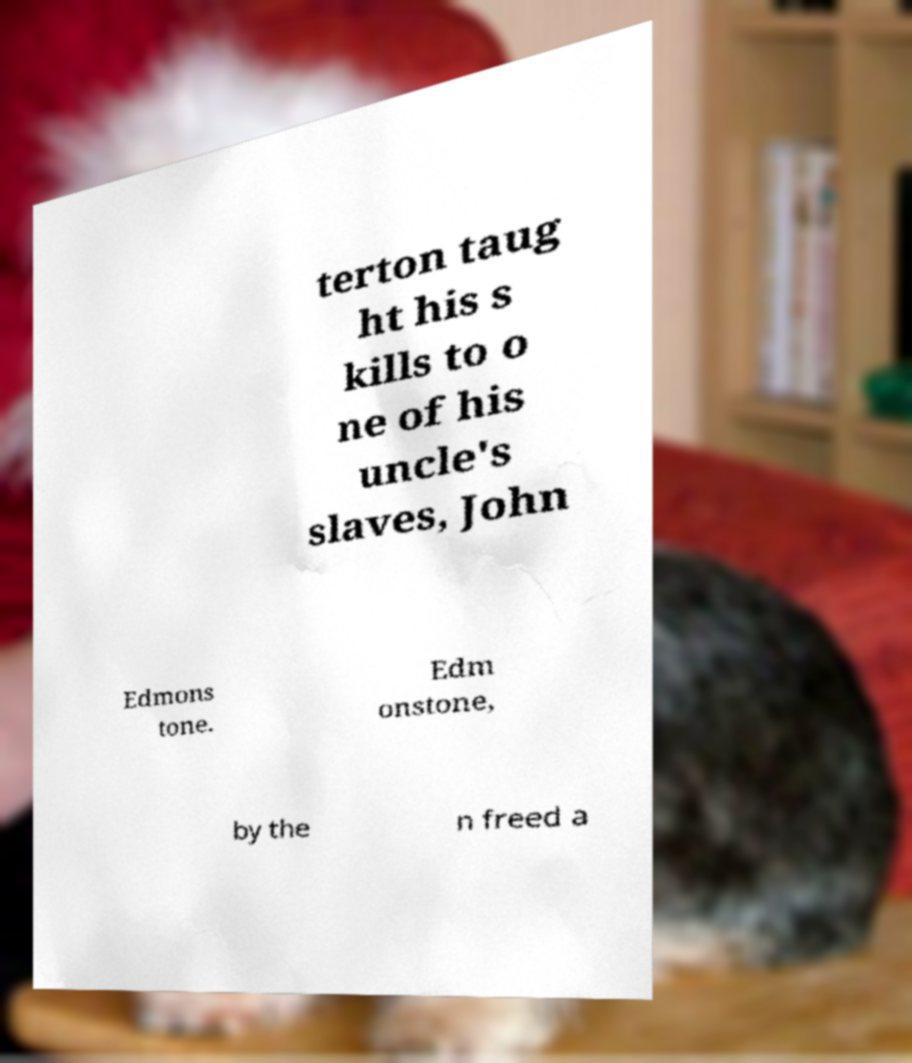Could you assist in decoding the text presented in this image and type it out clearly? terton taug ht his s kills to o ne of his uncle's slaves, John Edmons tone. Edm onstone, by the n freed a 